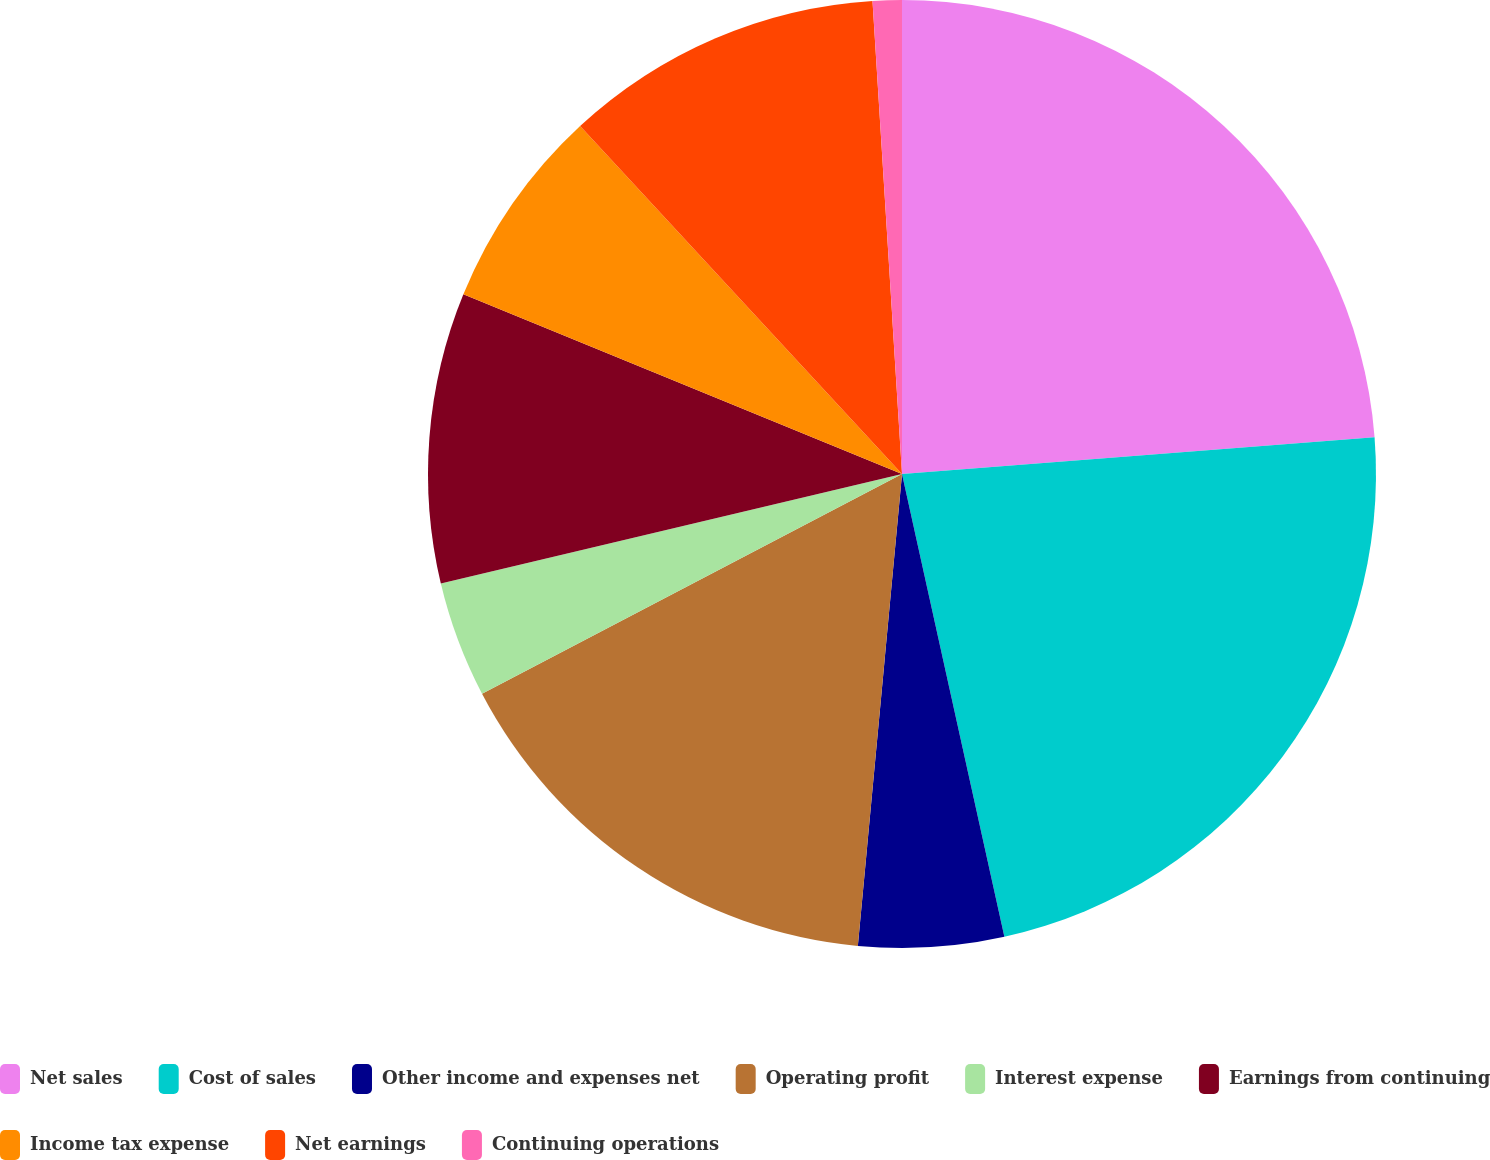<chart> <loc_0><loc_0><loc_500><loc_500><pie_chart><fcel>Net sales<fcel>Cost of sales<fcel>Other income and expenses net<fcel>Operating profit<fcel>Interest expense<fcel>Earnings from continuing<fcel>Income tax expense<fcel>Net earnings<fcel>Continuing operations<nl><fcel>23.76%<fcel>22.77%<fcel>4.95%<fcel>15.84%<fcel>3.96%<fcel>9.9%<fcel>6.93%<fcel>10.89%<fcel>0.99%<nl></chart> 